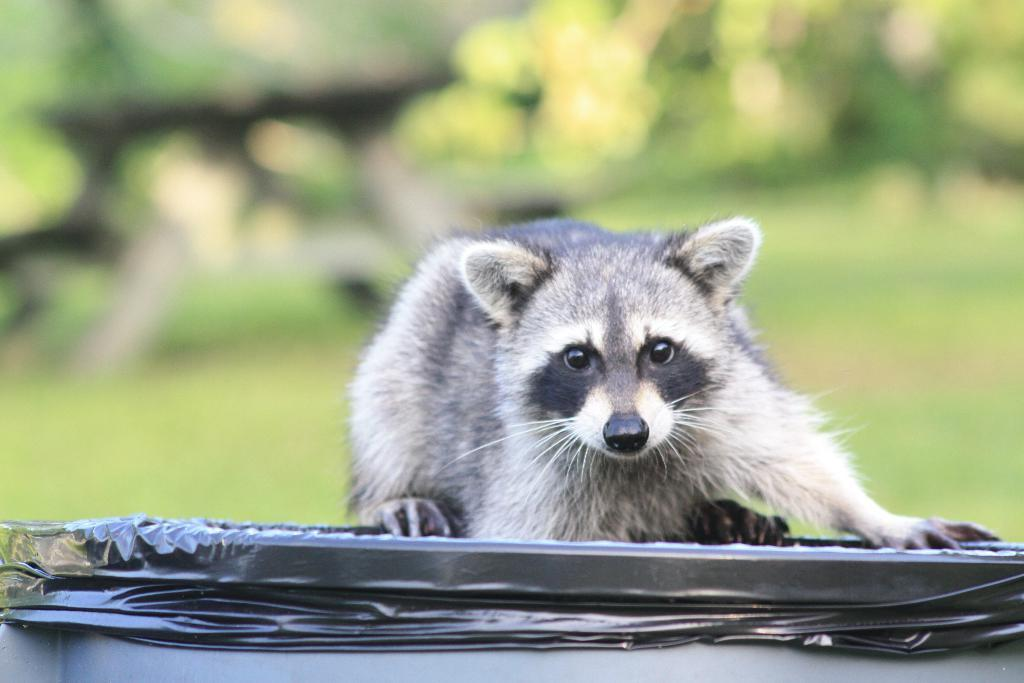What animal is in the center of the image? There is a raccoon in the center of the image. What color is the raccoon and the object it is on? The raccoon and the object it is on are in black and white color. What is the raccoon standing on? The raccoon is on a black object. What can be seen in the background of the image? There are trees in the background of the image. What historical event is depicted in the image? There is no historical event depicted in the image; it features a raccoon on a black object with trees in the background. What type of chalk is used to draw the raccoon in the image? There is no chalk used in the image; it is a photograph or illustration in black and white. 